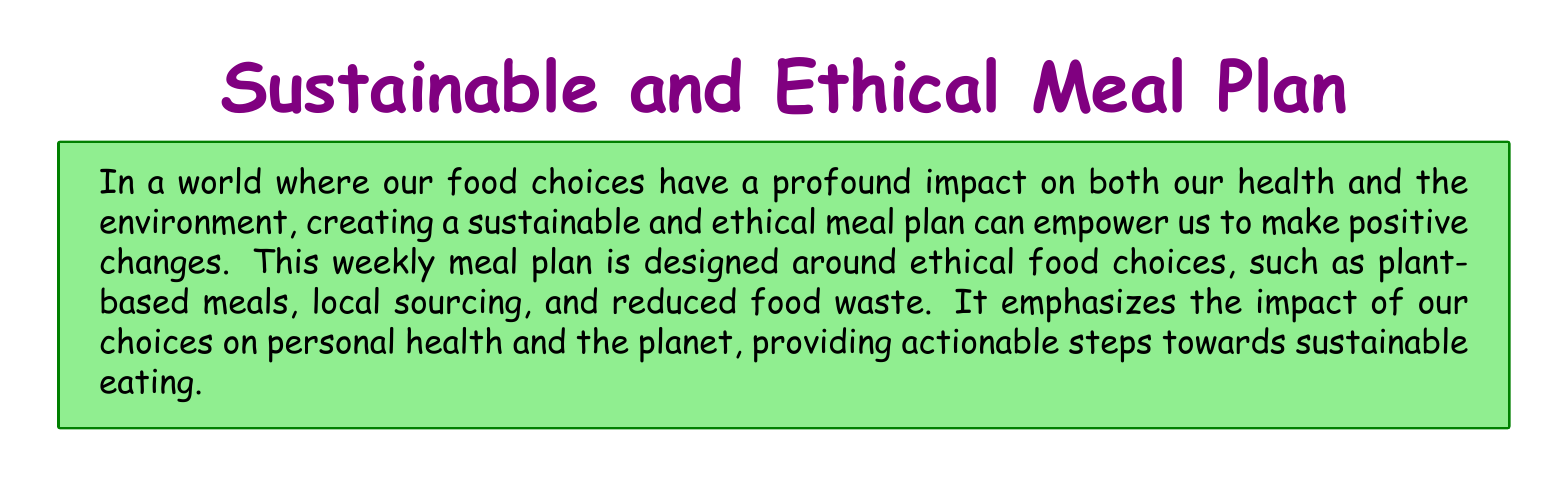What is the main focus of the meal plan? The meal plan focuses on ethical food choices, such as plant-based meals, local sourcing, and reduced food waste.
Answer: Ethical food choices How many meals are planned for each day? The document outlines three meals for each day of the week: breakfast, lunch, and dinner.
Answer: Three What day features a smoothie bowl for breakfast? The smoothie bowl is specifically mentioned for breakfast on Tuesday.
Answer: Tuesday What meal includes stuffed bell peppers? Stuffed bell peppers are included for dinner on Tuesday.
Answer: Dinner What is one of the additional tips provided in the document? One additional tip suggests focusing on consuming more plant-based foods.
Answer: Consume more plant-based foods How many different meals are listed for Saturday? There are three meals listed for Saturday: breakfast, lunch, and dinner.
Answer: Three Which ingredient is featured in the Monday dinner? The dinner on Monday includes lentils.
Answer: Lentils What is a suggested action to reduce food waste? The document suggests planning meals in advance to reduce food waste.
Answer: Plan meals in advance Which day has pancakes in the breakfast option? Pancakes are mentioned for breakfast on Sunday.
Answer: Sunday 